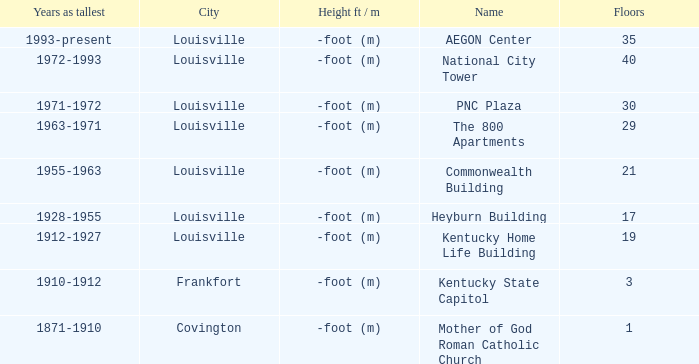In what city does the tallest building have 35 floors? Louisville. 